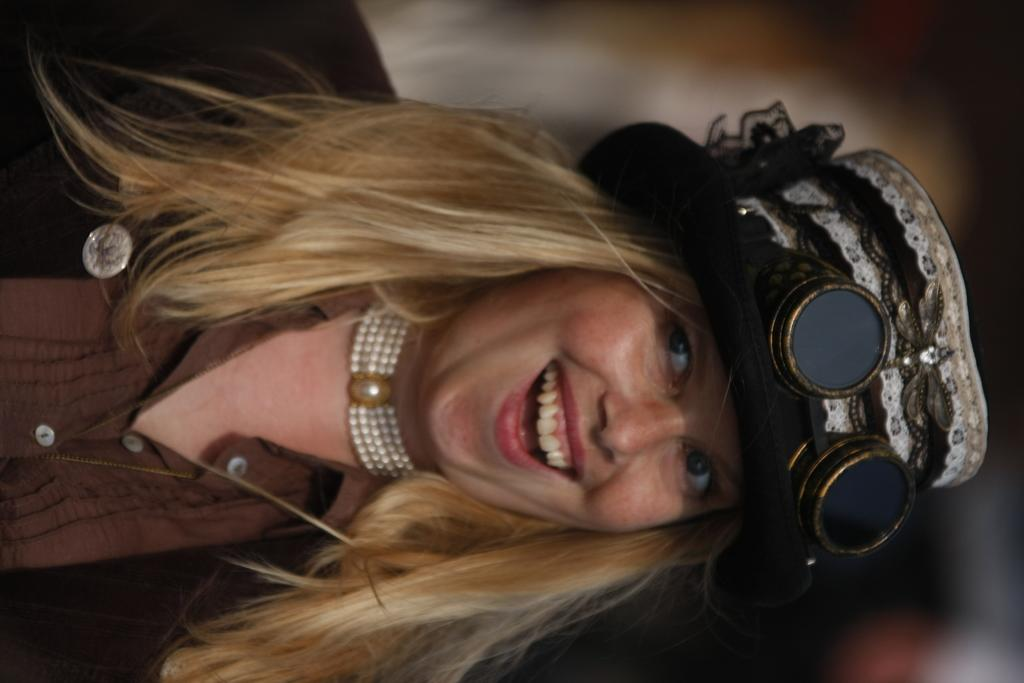Who is the main subject in the image? There is a lady in the image. What is the lady wearing on her head? The lady is wearing a cap. What color is the jacket the lady is wearing? The lady is wearing a brown color jacket. How many chairs are visible in the image? There are no chairs visible in the image; it only features a lady wearing a cap and a brown color jacket. 